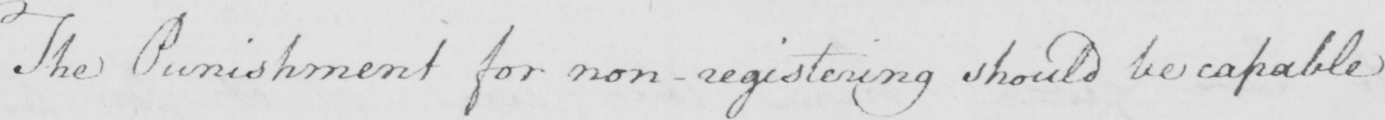Please provide the text content of this handwritten line. The Punishment for non-registering should be capable . 